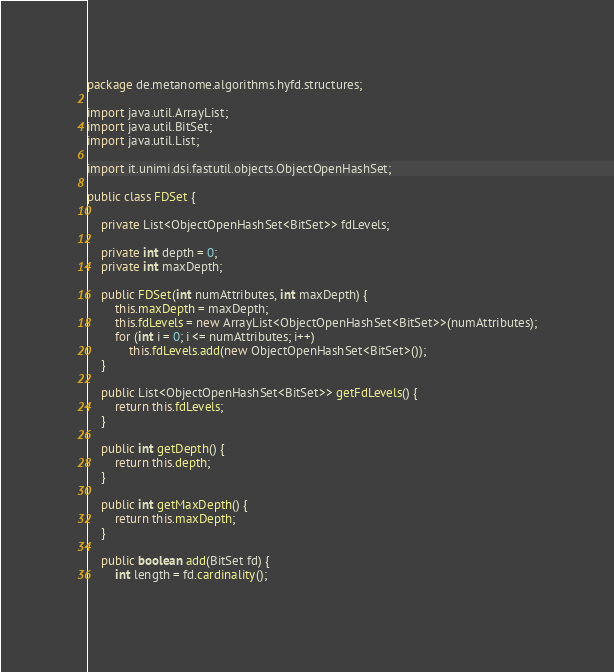Convert code to text. <code><loc_0><loc_0><loc_500><loc_500><_Java_>package de.metanome.algorithms.hyfd.structures;

import java.util.ArrayList;
import java.util.BitSet;
import java.util.List;

import it.unimi.dsi.fastutil.objects.ObjectOpenHashSet;

public class FDSet {

	private List<ObjectOpenHashSet<BitSet>> fdLevels;
	
	private int depth = 0;
	private int maxDepth;
	
	public FDSet(int numAttributes, int maxDepth) {
		this.maxDepth = maxDepth;
		this.fdLevels = new ArrayList<ObjectOpenHashSet<BitSet>>(numAttributes);
		for (int i = 0; i <= numAttributes; i++)
			this.fdLevels.add(new ObjectOpenHashSet<BitSet>());
	}

	public List<ObjectOpenHashSet<BitSet>> getFdLevels() {
		return this.fdLevels;
	}

	public int getDepth() {
		return this.depth;
	}

	public int getMaxDepth() {
		return this.maxDepth;
	}

	public boolean add(BitSet fd) {
		int length = fd.cardinality();
		</code> 